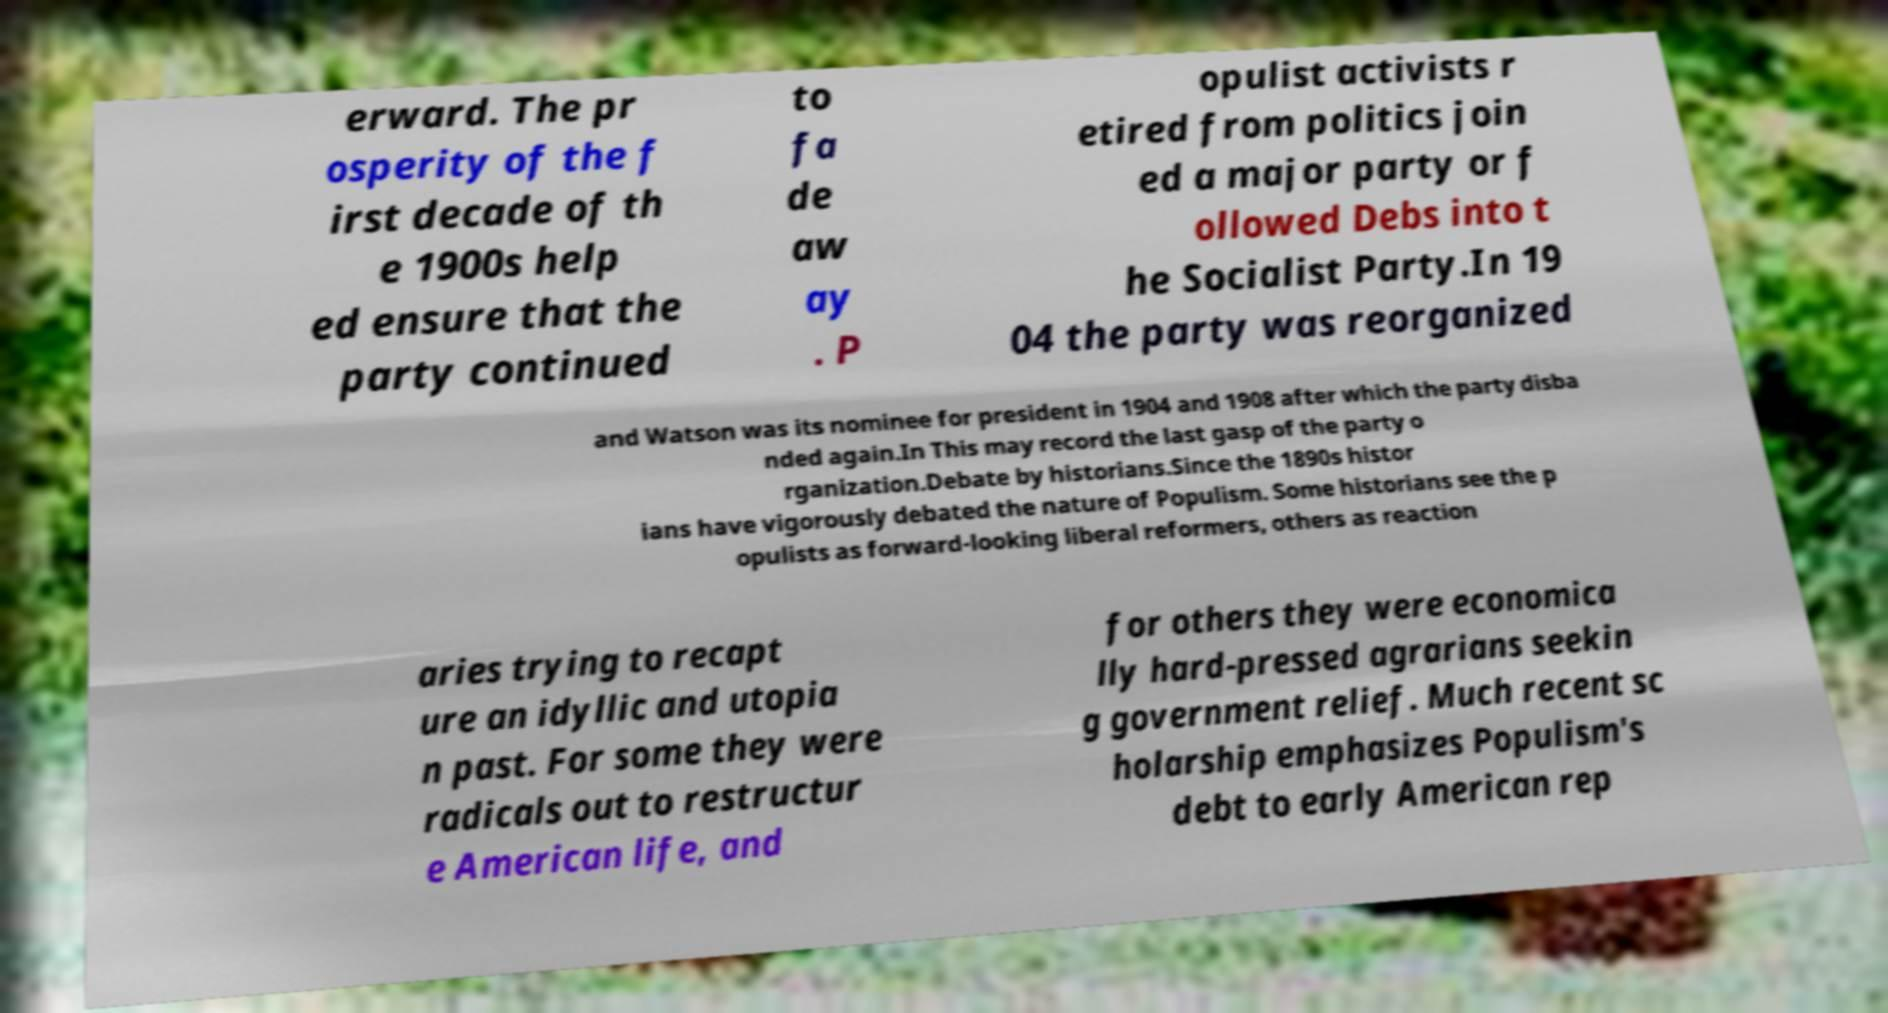Could you extract and type out the text from this image? erward. The pr osperity of the f irst decade of th e 1900s help ed ensure that the party continued to fa de aw ay . P opulist activists r etired from politics join ed a major party or f ollowed Debs into t he Socialist Party.In 19 04 the party was reorganized and Watson was its nominee for president in 1904 and 1908 after which the party disba nded again.In This may record the last gasp of the party o rganization.Debate by historians.Since the 1890s histor ians have vigorously debated the nature of Populism. Some historians see the p opulists as forward-looking liberal reformers, others as reaction aries trying to recapt ure an idyllic and utopia n past. For some they were radicals out to restructur e American life, and for others they were economica lly hard-pressed agrarians seekin g government relief. Much recent sc holarship emphasizes Populism's debt to early American rep 